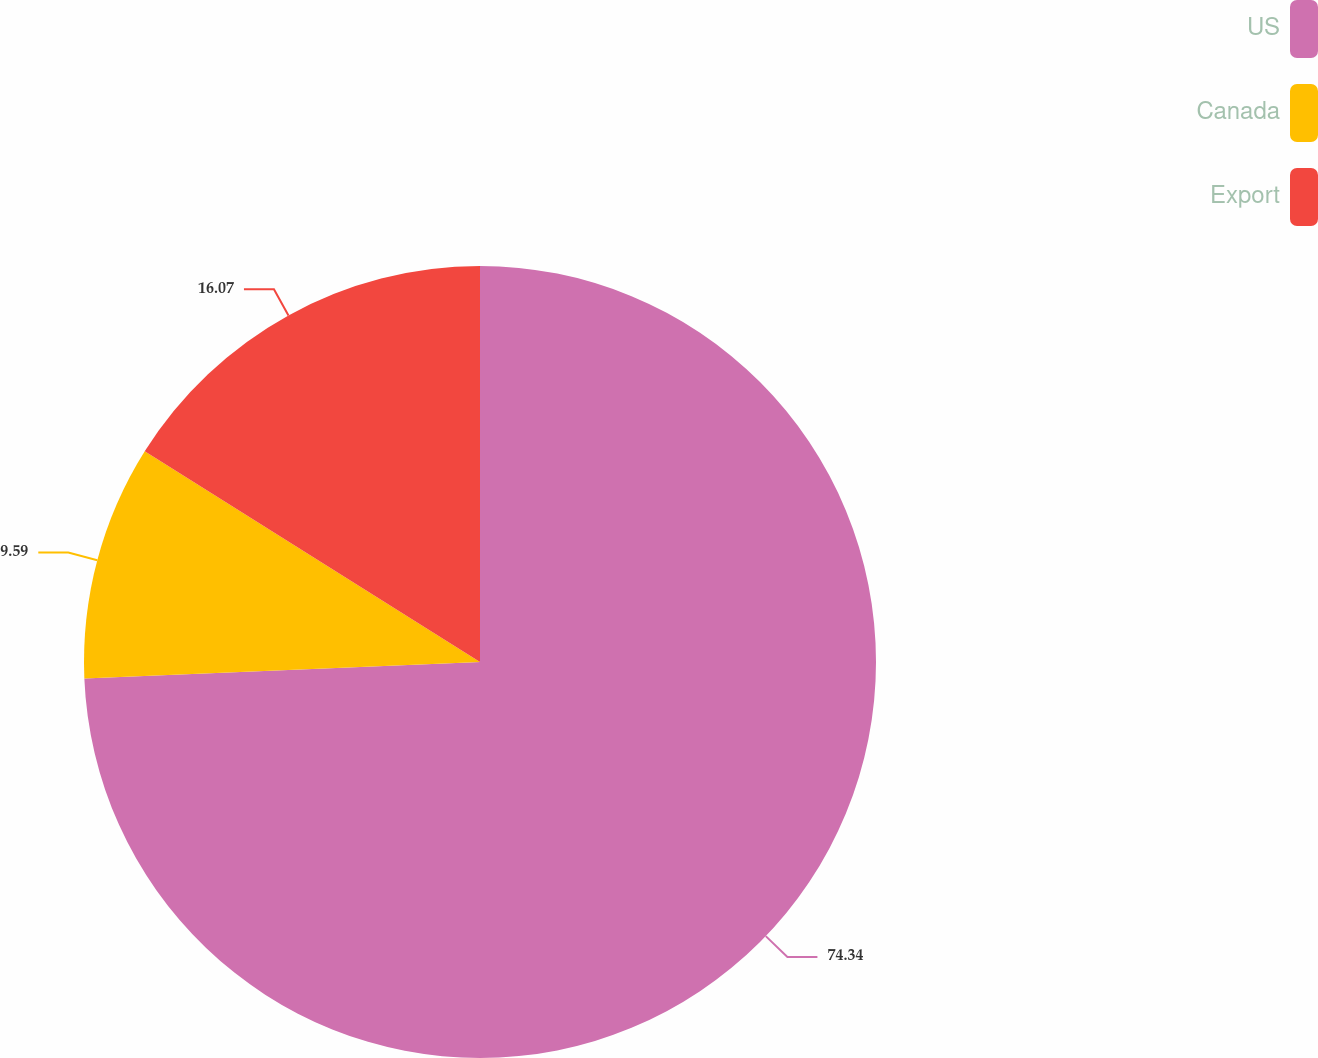Convert chart to OTSL. <chart><loc_0><loc_0><loc_500><loc_500><pie_chart><fcel>US<fcel>Canada<fcel>Export<nl><fcel>74.34%<fcel>9.59%<fcel>16.07%<nl></chart> 